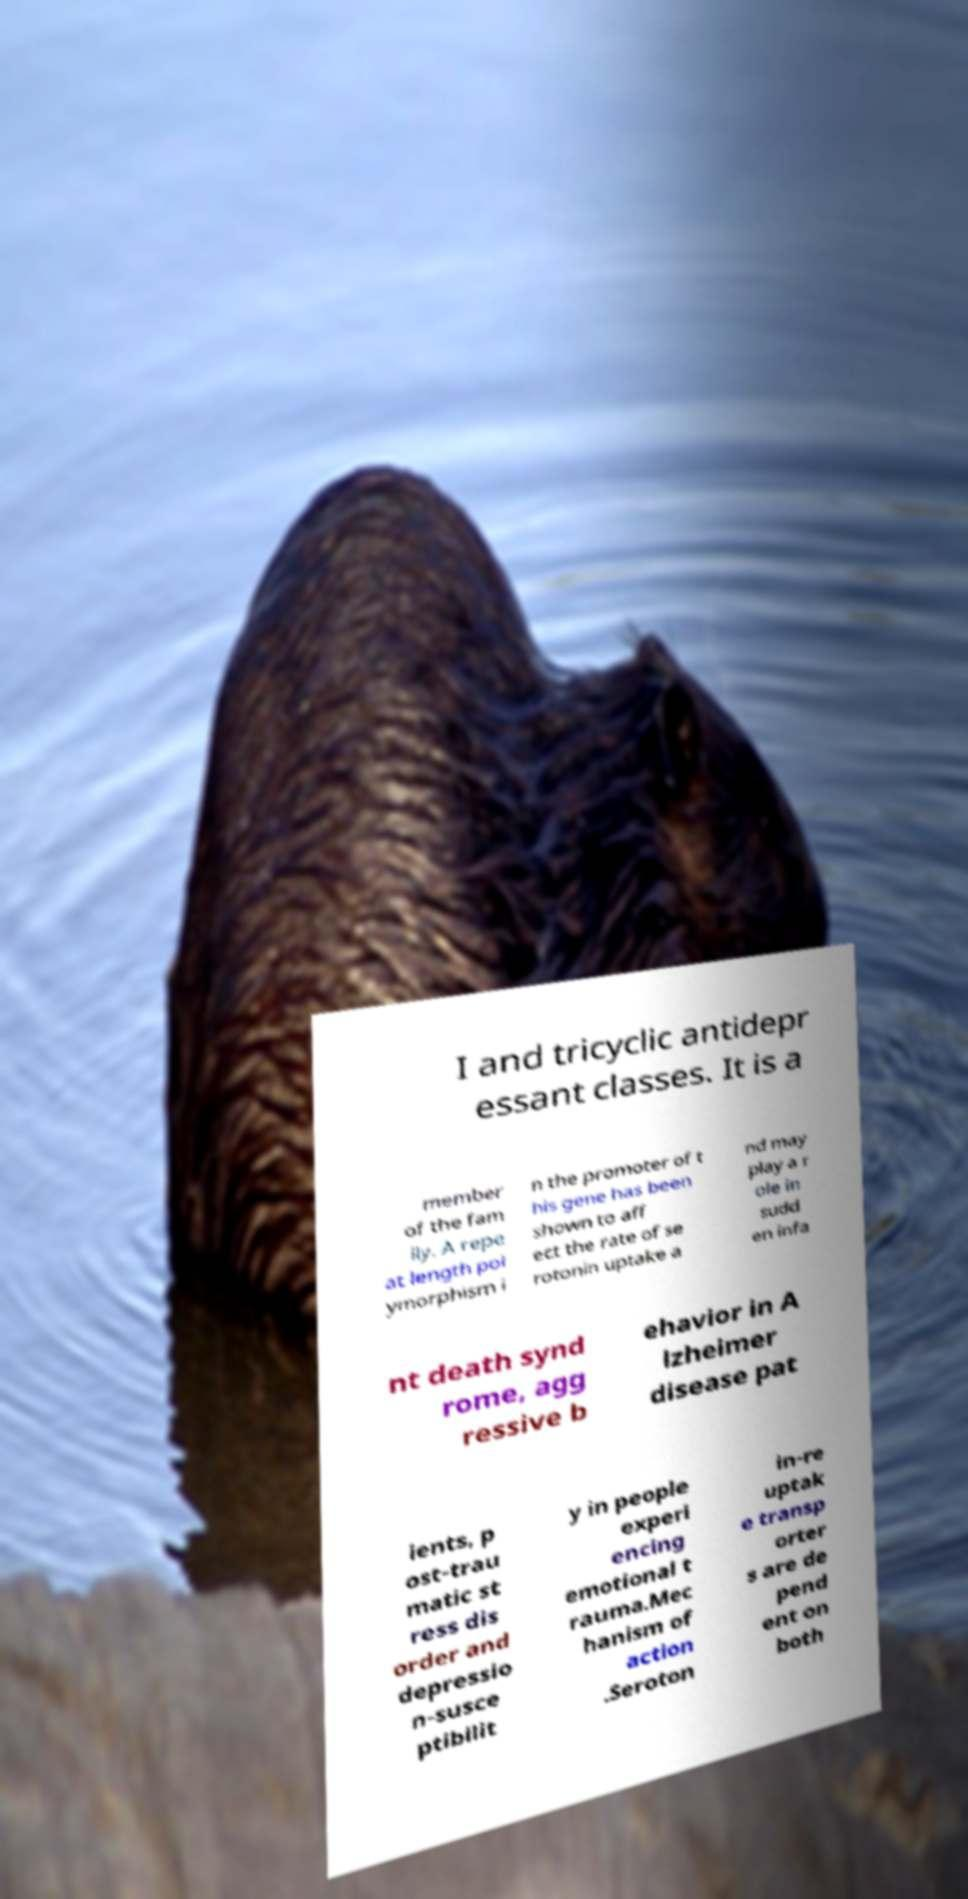Can you accurately transcribe the text from the provided image for me? I and tricyclic antidepr essant classes. It is a member of the fam ily. A repe at length pol ymorphism i n the promoter of t his gene has been shown to aff ect the rate of se rotonin uptake a nd may play a r ole in sudd en infa nt death synd rome, agg ressive b ehavior in A lzheimer disease pat ients, p ost-trau matic st ress dis order and depressio n-susce ptibilit y in people experi encing emotional t rauma.Mec hanism of action .Seroton in-re uptak e transp orter s are de pend ent on both 